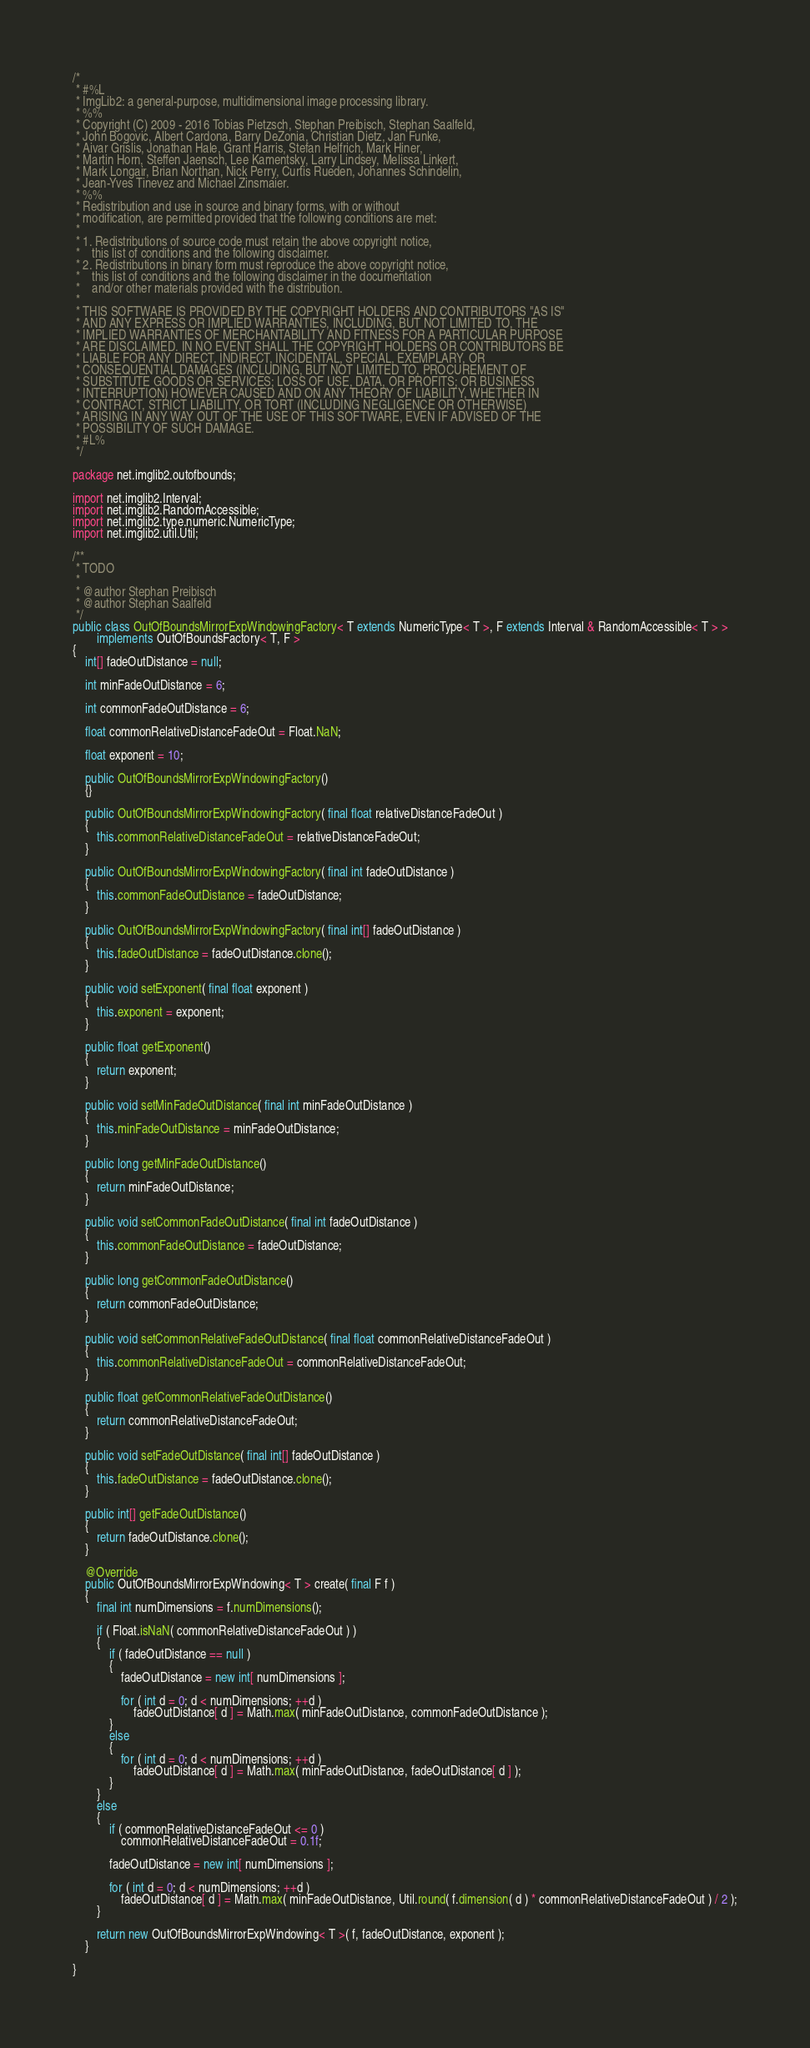Convert code to text. <code><loc_0><loc_0><loc_500><loc_500><_Java_>/*
 * #%L
 * ImgLib2: a general-purpose, multidimensional image processing library.
 * %%
 * Copyright (C) 2009 - 2016 Tobias Pietzsch, Stephan Preibisch, Stephan Saalfeld,
 * John Bogovic, Albert Cardona, Barry DeZonia, Christian Dietz, Jan Funke,
 * Aivar Grislis, Jonathan Hale, Grant Harris, Stefan Helfrich, Mark Hiner,
 * Martin Horn, Steffen Jaensch, Lee Kamentsky, Larry Lindsey, Melissa Linkert,
 * Mark Longair, Brian Northan, Nick Perry, Curtis Rueden, Johannes Schindelin,
 * Jean-Yves Tinevez and Michael Zinsmaier.
 * %%
 * Redistribution and use in source and binary forms, with or without
 * modification, are permitted provided that the following conditions are met:
 * 
 * 1. Redistributions of source code must retain the above copyright notice,
 *    this list of conditions and the following disclaimer.
 * 2. Redistributions in binary form must reproduce the above copyright notice,
 *    this list of conditions and the following disclaimer in the documentation
 *    and/or other materials provided with the distribution.
 * 
 * THIS SOFTWARE IS PROVIDED BY THE COPYRIGHT HOLDERS AND CONTRIBUTORS "AS IS"
 * AND ANY EXPRESS OR IMPLIED WARRANTIES, INCLUDING, BUT NOT LIMITED TO, THE
 * IMPLIED WARRANTIES OF MERCHANTABILITY AND FITNESS FOR A PARTICULAR PURPOSE
 * ARE DISCLAIMED. IN NO EVENT SHALL THE COPYRIGHT HOLDERS OR CONTRIBUTORS BE
 * LIABLE FOR ANY DIRECT, INDIRECT, INCIDENTAL, SPECIAL, EXEMPLARY, OR
 * CONSEQUENTIAL DAMAGES (INCLUDING, BUT NOT LIMITED TO, PROCUREMENT OF
 * SUBSTITUTE GOODS OR SERVICES; LOSS OF USE, DATA, OR PROFITS; OR BUSINESS
 * INTERRUPTION) HOWEVER CAUSED AND ON ANY THEORY OF LIABILITY, WHETHER IN
 * CONTRACT, STRICT LIABILITY, OR TORT (INCLUDING NEGLIGENCE OR OTHERWISE)
 * ARISING IN ANY WAY OUT OF THE USE OF THIS SOFTWARE, EVEN IF ADVISED OF THE
 * POSSIBILITY OF SUCH DAMAGE.
 * #L%
 */

package net.imglib2.outofbounds;

import net.imglib2.Interval;
import net.imglib2.RandomAccessible;
import net.imglib2.type.numeric.NumericType;
import net.imglib2.util.Util;

/**
 * TODO
 * 
 * @author Stephan Preibisch
 * @author Stephan Saalfeld
 */
public class OutOfBoundsMirrorExpWindowingFactory< T extends NumericType< T >, F extends Interval & RandomAccessible< T > >
		implements OutOfBoundsFactory< T, F >
{
	int[] fadeOutDistance = null;

	int minFadeOutDistance = 6;

	int commonFadeOutDistance = 6;

	float commonRelativeDistanceFadeOut = Float.NaN;

	float exponent = 10;

	public OutOfBoundsMirrorExpWindowingFactory()
	{}

	public OutOfBoundsMirrorExpWindowingFactory( final float relativeDistanceFadeOut )
	{
		this.commonRelativeDistanceFadeOut = relativeDistanceFadeOut;
	}

	public OutOfBoundsMirrorExpWindowingFactory( final int fadeOutDistance )
	{
		this.commonFadeOutDistance = fadeOutDistance;
	}

	public OutOfBoundsMirrorExpWindowingFactory( final int[] fadeOutDistance )
	{
		this.fadeOutDistance = fadeOutDistance.clone();
	}

	public void setExponent( final float exponent )
	{
		this.exponent = exponent;
	}

	public float getExponent()
	{
		return exponent;
	}

	public void setMinFadeOutDistance( final int minFadeOutDistance )
	{
		this.minFadeOutDistance = minFadeOutDistance;
	}

	public long getMinFadeOutDistance()
	{
		return minFadeOutDistance;
	}

	public void setCommonFadeOutDistance( final int fadeOutDistance )
	{
		this.commonFadeOutDistance = fadeOutDistance;
	}

	public long getCommonFadeOutDistance()
	{
		return commonFadeOutDistance;
	}

	public void setCommonRelativeFadeOutDistance( final float commonRelativeDistanceFadeOut )
	{
		this.commonRelativeDistanceFadeOut = commonRelativeDistanceFadeOut;
	}

	public float getCommonRelativeFadeOutDistance()
	{
		return commonRelativeDistanceFadeOut;
	}

	public void setFadeOutDistance( final int[] fadeOutDistance )
	{
		this.fadeOutDistance = fadeOutDistance.clone();
	}

	public int[] getFadeOutDistance()
	{
		return fadeOutDistance.clone();
	}

	@Override
	public OutOfBoundsMirrorExpWindowing< T > create( final F f )
	{
		final int numDimensions = f.numDimensions();

		if ( Float.isNaN( commonRelativeDistanceFadeOut ) )
		{
			if ( fadeOutDistance == null )
			{
				fadeOutDistance = new int[ numDimensions ];

				for ( int d = 0; d < numDimensions; ++d )
					fadeOutDistance[ d ] = Math.max( minFadeOutDistance, commonFadeOutDistance );
			}
			else
			{
				for ( int d = 0; d < numDimensions; ++d )
					fadeOutDistance[ d ] = Math.max( minFadeOutDistance, fadeOutDistance[ d ] );
			}
		}
		else
		{
			if ( commonRelativeDistanceFadeOut <= 0 )
				commonRelativeDistanceFadeOut = 0.1f;

			fadeOutDistance = new int[ numDimensions ];

			for ( int d = 0; d < numDimensions; ++d )
				fadeOutDistance[ d ] = Math.max( minFadeOutDistance, Util.round( f.dimension( d ) * commonRelativeDistanceFadeOut ) / 2 );
		}

		return new OutOfBoundsMirrorExpWindowing< T >( f, fadeOutDistance, exponent );
	}

}
</code> 